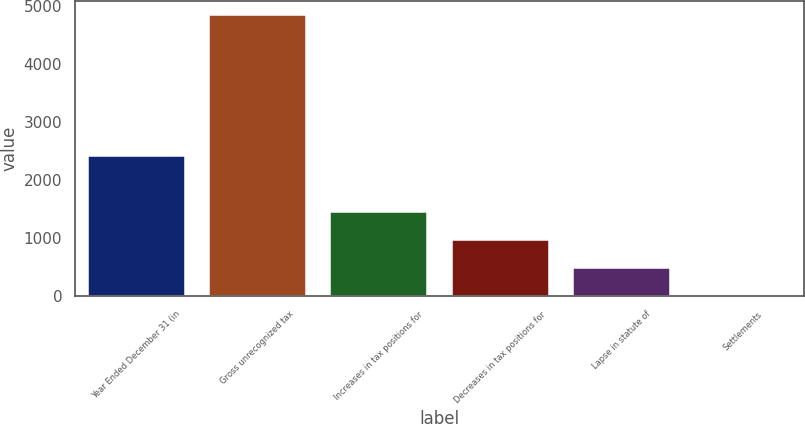<chart> <loc_0><loc_0><loc_500><loc_500><bar_chart><fcel>Year Ended December 31 (in<fcel>Gross unrecognized tax<fcel>Increases in tax positions for<fcel>Decreases in tax positions for<fcel>Lapse in statute of<fcel>Settlements<nl><fcel>2426<fcel>4843<fcel>1459.2<fcel>975.8<fcel>492.4<fcel>9<nl></chart> 